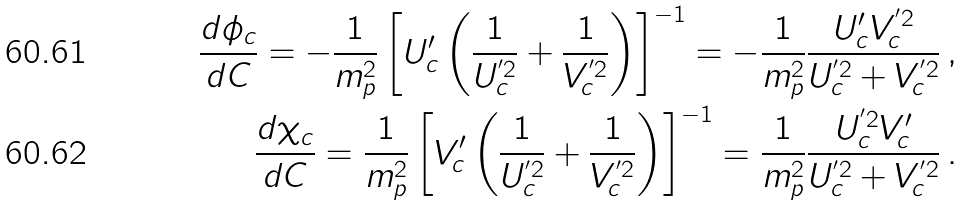Convert formula to latex. <formula><loc_0><loc_0><loc_500><loc_500>\frac { d \phi _ { c } } { d C } = - \frac { 1 } { m _ { p } ^ { 2 } } \left [ U ^ { \prime } _ { c } \left ( \frac { 1 } { U ^ { ^ { \prime } 2 } _ { c } } + \frac { 1 } { V ^ { ^ { \prime } 2 } _ { c } } \right ) \right ] ^ { - 1 } = - \frac { 1 } { m _ { p } ^ { 2 } } \frac { U ^ { \prime } _ { c } V ^ { ^ { \prime } 2 } _ { c } } { U ^ { ^ { \prime } 2 } _ { c } + V ^ { ^ { \prime } 2 } _ { c } } \, , \\ \frac { d \chi _ { c } } { d C } = \frac { 1 } { m _ { p } ^ { 2 } } \left [ V ^ { \prime } _ { c } \left ( \frac { 1 } { U ^ { ^ { \prime } 2 } _ { c } } + \frac { 1 } { V ^ { ^ { \prime } 2 } _ { c } } \right ) \right ] ^ { - 1 } = \frac { 1 } { m _ { p } ^ { 2 } } \frac { U ^ { ^ { \prime } 2 } _ { c } V ^ { \prime } _ { c } } { U ^ { ^ { \prime } 2 } _ { c } + V ^ { ^ { \prime } 2 } _ { c } } \, .</formula> 